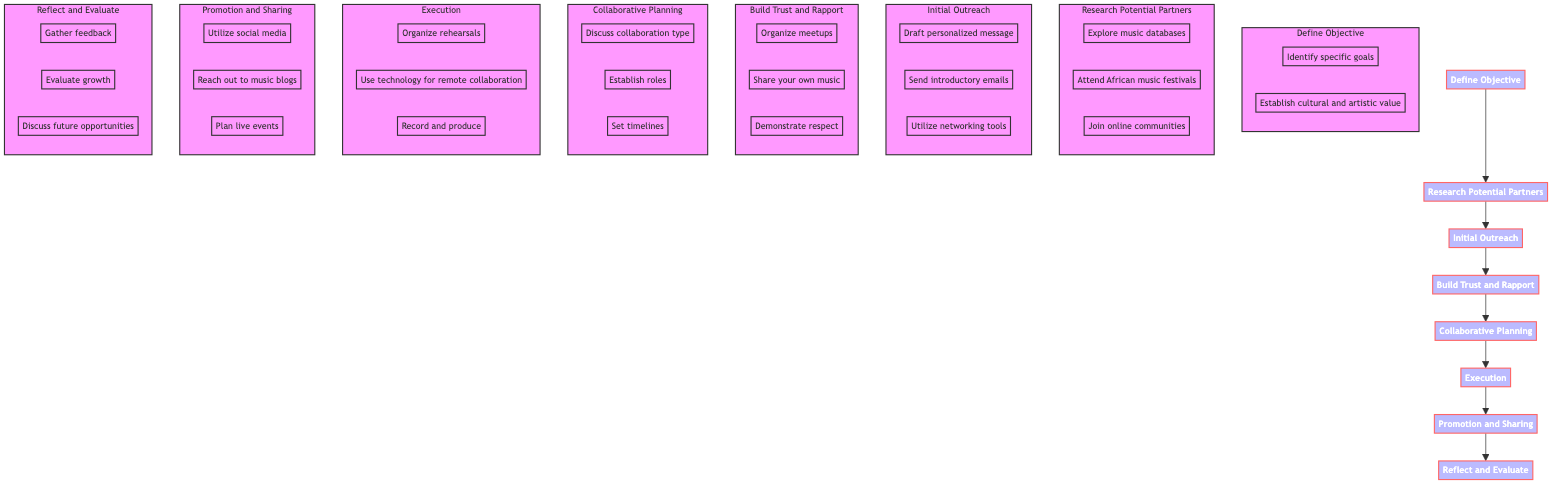What is the first step in the flowchart? The first step is labeled as "Define Objective." It is the initial node from which the process begins, indicating the starting point of networking and collaborating.
Answer: Define Objective How many main stages are there in the diagram? The diagram contains eight main stages, as indicated by the primary nodes in the flowchart that follow one another in a sequence. Counting these nodes reveals the total number of main stages.
Answer: Eight Which task is included under "Research Potential Partners"? One of the tasks included under "Research Potential Partners" is "Explore music databases." This task is specifically listed within the subgraph corresponding to this main stage.
Answer: Explore music databases What is required after "Initial Outreach"? After "Initial Outreach," the next step is "Build Trust and Rapport." This is established by following the directional flow of the diagram from one stage to the next.
Answer: Build Trust and Rapport Which node focuses on assessing collaboration outcomes? The node titled "Reflect and Evaluate" is focused on assessing the outcomes of the collaboration. This node represents the final stage where participants review their experience and results.
Answer: Reflect and Evaluate How does "Build Trust and Rapport" relate to "Collaborative Planning"? "Build Trust and Rapport" directly precedes "Collaborative Planning" in the sequence, indicating that developing a strong relationship is essential before discussions about the actual planning of the collaboration can occur.
Answer: Directly precedes What is one task associated with "Execution"? One task associated with "Execution" is "Organize rehearsal sessions." This specific task is listed as a part of the execution phase, highlighting what needs to be done during this stage.
Answer: Organize rehearsal sessions How many tasks are listed under the "Promotion and Sharing" section? There are three tasks listed under the "Promotion and Sharing" section, as indicated by the three nodes extending from that particular stage in the flowchart.
Answer: Three What is the purpose of "Define Objective"? The purpose of "Define Objective" is to clarify the purpose and what you hope to achieve by collaborating. This overarching goal is essential for guiding the collaboration process effectively.
Answer: Clarify the purpose 